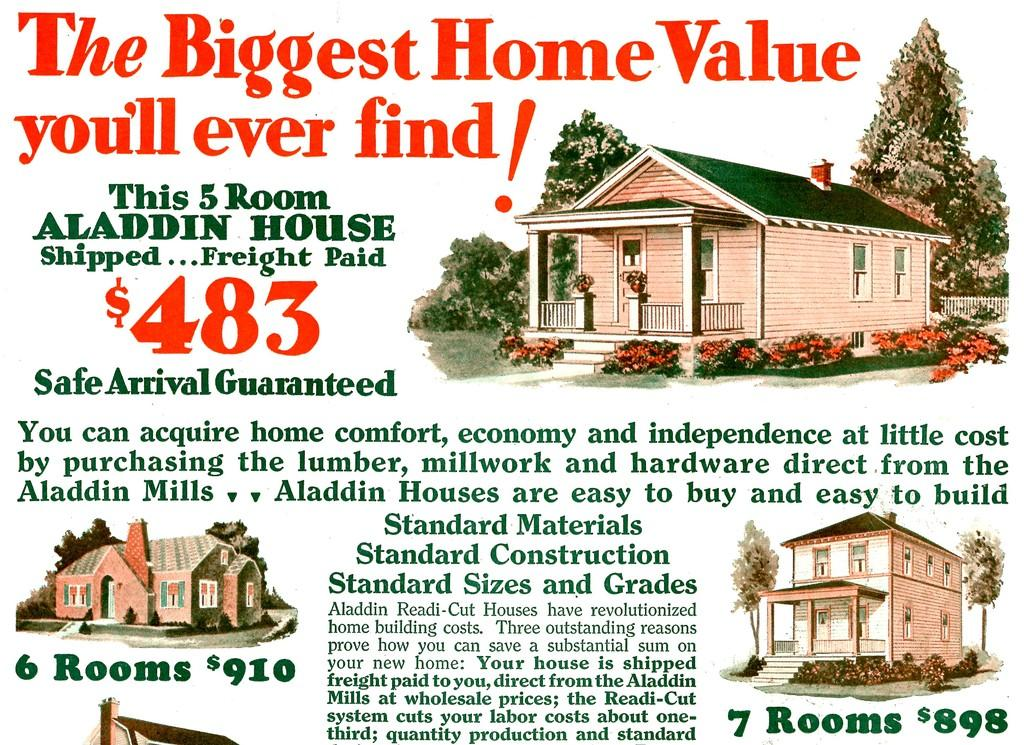What type of structures can be seen in the image? There are houses in the image. What other natural elements are present in the image? There are trees in the image. Is there any text visible in the image? Yes, there is some text in the image. What type of content does the image represent? The image is an article. What type of copy is being used in the image? There is no mention of copy in the provided facts, so it cannot be determined from the image. 